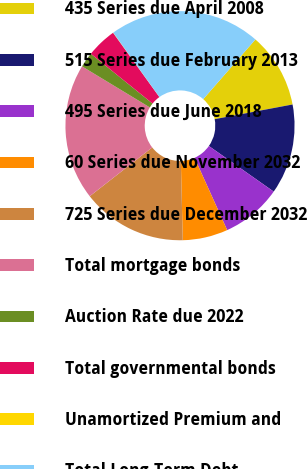Convert chart. <chart><loc_0><loc_0><loc_500><loc_500><pie_chart><fcel>435 Series due April 2008<fcel>515 Series due February 2013<fcel>495 Series due June 2018<fcel>60 Series due November 2032<fcel>725 Series due December 2032<fcel>Total mortgage bonds<fcel>Auction Rate due 2022<fcel>Total governmental bonds<fcel>Unamortized Premium and<fcel>Total Long-Term Debt<nl><fcel>10.6%<fcel>12.72%<fcel>8.49%<fcel>6.37%<fcel>14.83%<fcel>19.22%<fcel>2.14%<fcel>4.26%<fcel>0.03%<fcel>21.34%<nl></chart> 